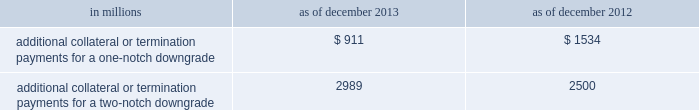Management 2019s discussion and analysis we believe our credit ratings are primarily based on the credit rating agencies 2019 assessment of : 2030 our liquidity , market , credit and operational risk management practices ; 2030 the level and variability of our earnings ; 2030 our capital base ; 2030 our franchise , reputation and management ; 2030 our corporate governance ; and 2030 the external operating environment , including the assumed level of government support .
Certain of the firm 2019s derivatives have been transacted under bilateral agreements with counterparties who may require us to post collateral or terminate the transactions based on changes in our credit ratings .
We assess the impact of these bilateral agreements by determining the collateral or termination payments that would occur assuming a downgrade by all rating agencies .
A downgrade by any one rating agency , depending on the agency 2019s relative ratings of the firm at the time of the downgrade , may have an impact which is comparable to the impact of a downgrade by all rating agencies .
We allocate a portion of our gce to ensure we would be able to make the additional collateral or termination payments that may be required in the event of a two-notch reduction in our long-term credit ratings , as well as collateral that has not been called by counterparties , but is available to them .
The table below presents the additional collateral or termination payments related to our net derivative liabilities under bilateral agreements that could have been called at the reporting date by counterparties in the event of a one-notch and two-notch downgrade in our credit ratings. .
In millions 2013 2012 additional collateral or termination payments for a one-notch downgrade $ 911 $ 1534 additional collateral or termination payments for a two-notch downgrade 2989 2500 cash flows as a global financial institution , our cash flows are complex and bear little relation to our net earnings and net assets .
Consequently , we believe that traditional cash flow analysis is less meaningful in evaluating our liquidity position than the excess liquidity and asset-liability management policies described above .
Cash flow analysis may , however , be helpful in highlighting certain macro trends and strategic initiatives in our businesses .
Year ended december 2013 .
Our cash and cash equivalents decreased by $ 11.54 billion to $ 61.13 billion at the end of 2013 .
We generated $ 4.54 billion in net cash from operating activities .
We used net cash of $ 16.08 billion for investing and financing activities , primarily to fund loans held for investment and repurchases of common stock .
Year ended december 2012 .
Our cash and cash equivalents increased by $ 16.66 billion to $ 72.67 billion at the end of 2012 .
We generated $ 9.14 billion in net cash from operating and investing activities .
We generated $ 7.52 billion in net cash from financing activities from an increase in bank deposits , partially offset by net repayments of unsecured and secured long-term borrowings .
Year ended december 2011 .
Our cash and cash equivalents increased by $ 16.22 billion to $ 56.01 billion at the end of 2011 .
We generated $ 23.13 billion in net cash from operating and investing activities .
We used net cash of $ 6.91 billion for financing activities , primarily for repurchases of our series g preferred stock and common stock , partially offset by an increase in bank deposits .
Goldman sachs 2013 annual report 89 .
For cash and cash equivalents at the end of 2013 , what percentage was generated from operating activities? 
Computations: (4.54 / 61.13)
Answer: 0.07427. 